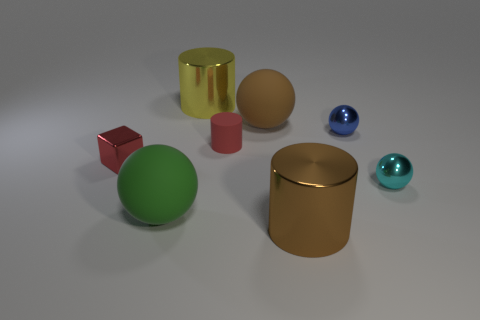Do the cube and the big ball that is in front of the red block have the same material?
Offer a terse response. No. What number of things are tiny red matte cylinders or large brown matte cylinders?
Give a very brief answer. 1. Are there any big yellow objects?
Provide a short and direct response. Yes. There is a brown thing right of the big ball that is behind the big green matte ball; what is its shape?
Ensure brevity in your answer.  Cylinder. What number of things are metallic objects on the left side of the cyan metallic ball or small red rubber objects that are right of the yellow cylinder?
Provide a short and direct response. 5. There is a cylinder that is the same size as the yellow shiny thing; what is it made of?
Give a very brief answer. Metal. The small rubber thing is what color?
Offer a very short reply. Red. The object that is both in front of the cyan ball and to the right of the small red rubber thing is made of what material?
Offer a terse response. Metal. There is a brown object that is to the right of the brown object that is left of the brown cylinder; are there any large brown things on the left side of it?
Your answer should be very brief. Yes. There is a rubber object that is the same color as the tiny cube; what size is it?
Your answer should be compact. Small. 